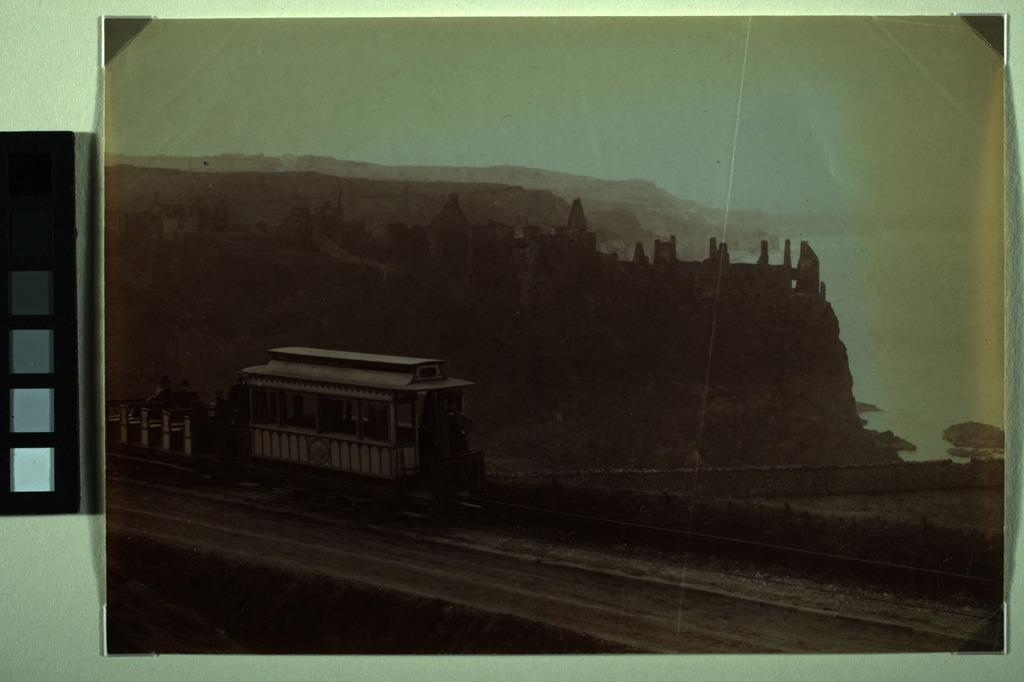What is present in the image? There is a frame in the image. Where is the frame located? The frame is placed on a wall. Can you see any spies hiding behind the frame in the image? There is no indication of any spies or hiding places in the image; it only features a frame placed on a wall. 